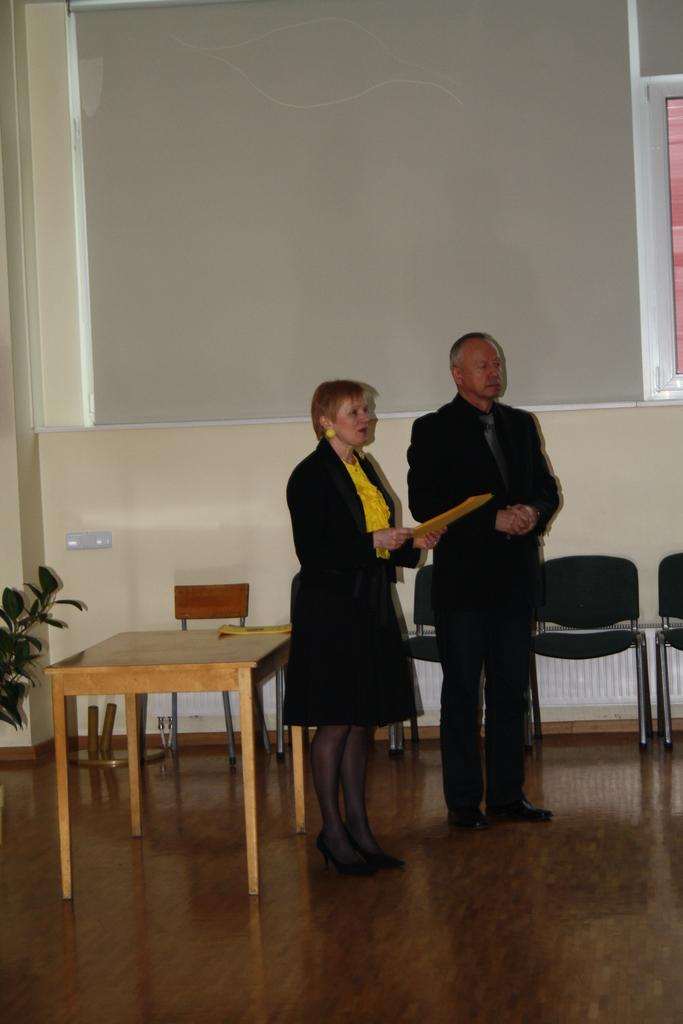How many people are in the image? There are two people in the image. What are the people doing in the image? The people are standing. What type of furniture is present in the image? There is a wooden table and chairs in the image. What is the woman holding in her hand? The woman is holding a file in her hand. Is there an umbrella open above the wooden table in the image? No, there is no umbrella present in the image. What type of powder is being used by the people in the image? There is no powder being used by the people in the image. 